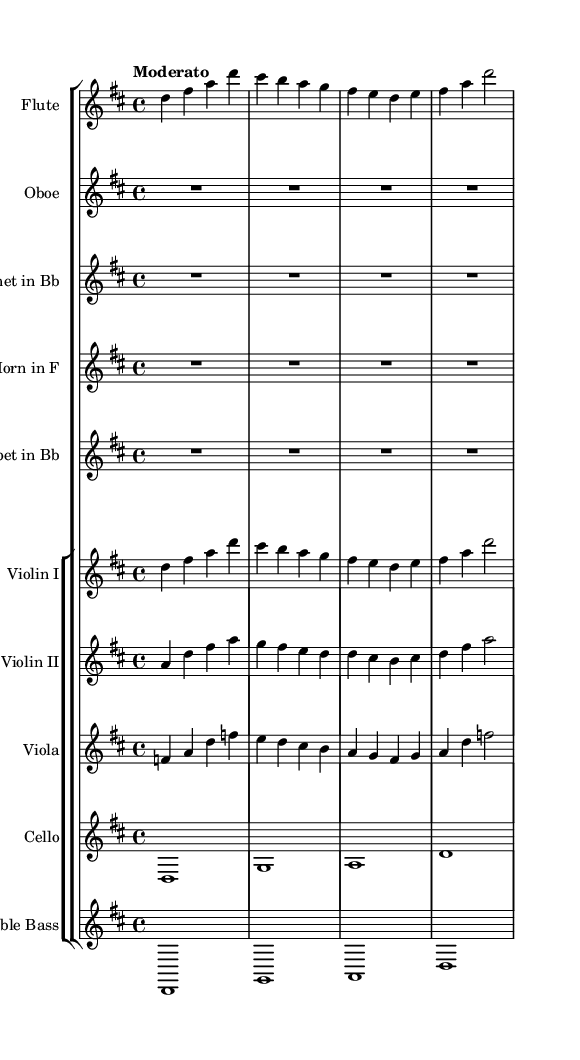what is the key signature of this music? The key signature is indicated by the presence of sharps or flats at the beginning of the staff. Looking at the clefs and key signature markings, we can see that there are two sharps (F# and C#), which corresponds to the key of D major.
Answer: D major what is the time signature of this music? The time signature appears at the beginning of the score, indicated by the numbers stacked vertically next to each other. In this case, it is shown as 4/4, which means there are four beats per measure.
Answer: 4/4 what is the tempo marking of this music? The tempo marking is usually written at the beginning of the score and indicates the speed of the piece. Here, it says "Moderato," which is a moderate tempo.
Answer: Moderato how many measures are present in the flute part? To find the number of measures in the flute part, we can visually count the vertical lines (bar lines) separating the measures. The flute part consists of four measures.
Answer: 4 which instrument plays the same melody as the Flute in the score? By examining the musical lines, we can see that the Violin I part is notated with the same pitch and rhythm as the Flute part, indicating they share the same melody.
Answer: Violin I how many beats are given to the entire cello part? The whole cello part is written as whole notes which, according to the time signature of 4/4, each whole note represents four beats. Since there are four whole notes, we calculate total beats as 4 notes x 4 beats each, yielding 16 beats total.
Answer: 16 how many different instruments are included in this symphonic piece? We identify the different staves in the score—the instruments listed are Flute, Oboe, Clarinet, Horn, Trumpet, Violin I, Violin II, Viola, Cello, and Double Bass. Counting these gives us ten unique instruments.
Answer: 10 